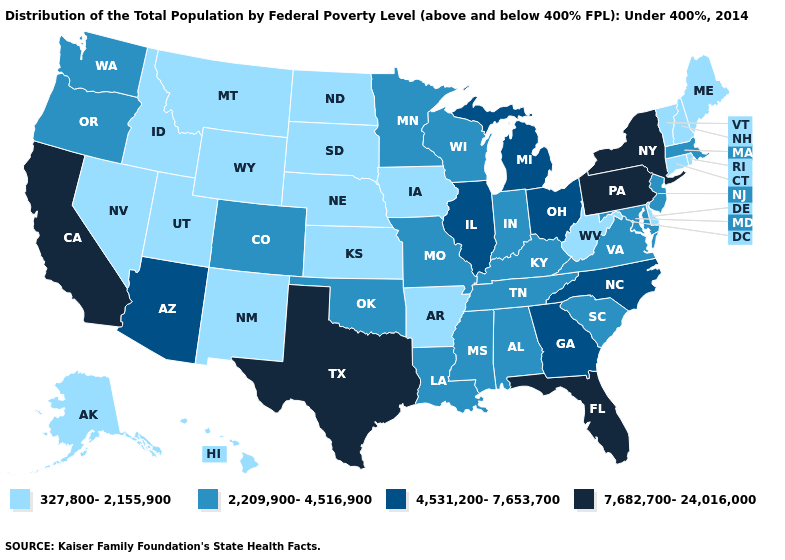Name the states that have a value in the range 7,682,700-24,016,000?
Be succinct. California, Florida, New York, Pennsylvania, Texas. Name the states that have a value in the range 2,209,900-4,516,900?
Write a very short answer. Alabama, Colorado, Indiana, Kentucky, Louisiana, Maryland, Massachusetts, Minnesota, Mississippi, Missouri, New Jersey, Oklahoma, Oregon, South Carolina, Tennessee, Virginia, Washington, Wisconsin. Name the states that have a value in the range 4,531,200-7,653,700?
Short answer required. Arizona, Georgia, Illinois, Michigan, North Carolina, Ohio. What is the highest value in the Northeast ?
Short answer required. 7,682,700-24,016,000. Name the states that have a value in the range 2,209,900-4,516,900?
Write a very short answer. Alabama, Colorado, Indiana, Kentucky, Louisiana, Maryland, Massachusetts, Minnesota, Mississippi, Missouri, New Jersey, Oklahoma, Oregon, South Carolina, Tennessee, Virginia, Washington, Wisconsin. Does Utah have the same value as Delaware?
Write a very short answer. Yes. Does New Jersey have a lower value than Tennessee?
Concise answer only. No. What is the highest value in the USA?
Give a very brief answer. 7,682,700-24,016,000. What is the highest value in the USA?
Give a very brief answer. 7,682,700-24,016,000. Name the states that have a value in the range 327,800-2,155,900?
Concise answer only. Alaska, Arkansas, Connecticut, Delaware, Hawaii, Idaho, Iowa, Kansas, Maine, Montana, Nebraska, Nevada, New Hampshire, New Mexico, North Dakota, Rhode Island, South Dakota, Utah, Vermont, West Virginia, Wyoming. Among the states that border Arkansas , does Texas have the highest value?
Write a very short answer. Yes. What is the highest value in states that border Tennessee?
Be succinct. 4,531,200-7,653,700. Name the states that have a value in the range 4,531,200-7,653,700?
Short answer required. Arizona, Georgia, Illinois, Michigan, North Carolina, Ohio. Does the map have missing data?
Be succinct. No. 